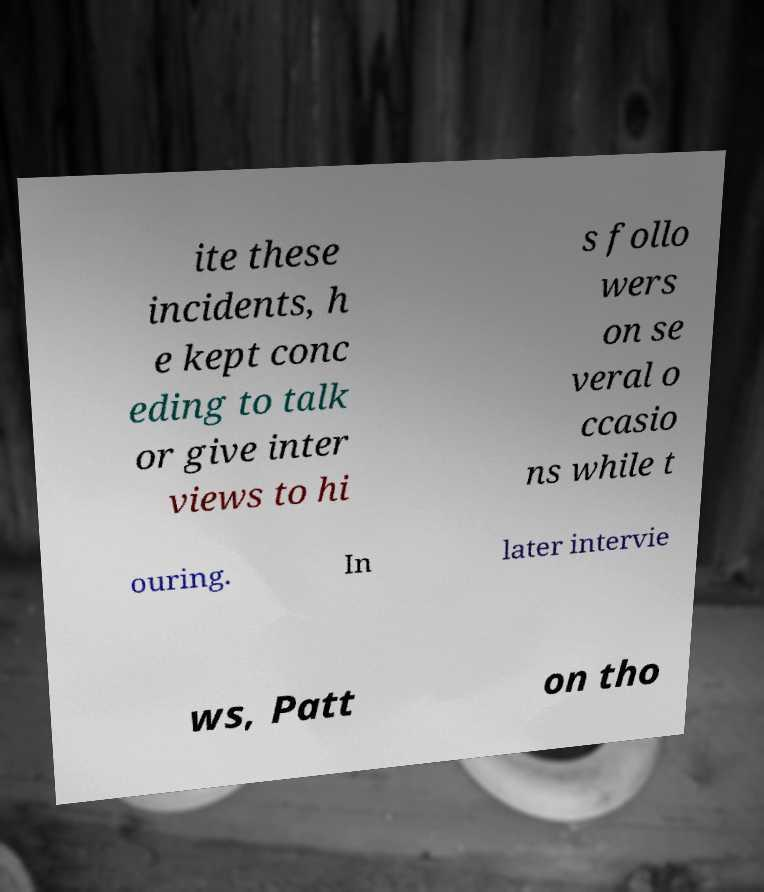Please identify and transcribe the text found in this image. ite these incidents, h e kept conc eding to talk or give inter views to hi s follo wers on se veral o ccasio ns while t ouring. In later intervie ws, Patt on tho 